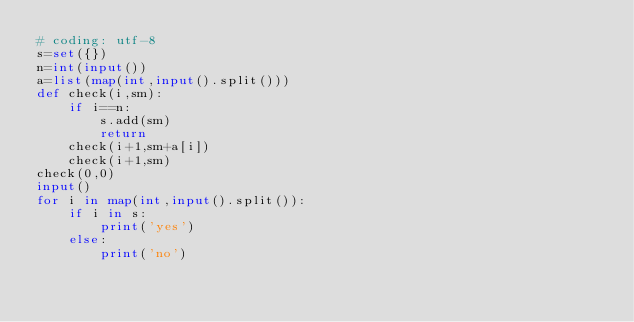<code> <loc_0><loc_0><loc_500><loc_500><_Python_># coding: utf-8
s=set({})
n=int(input())
a=list(map(int,input().split()))
def check(i,sm):
    if i==n:
        s.add(sm)
        return
    check(i+1,sm+a[i])
    check(i+1,sm)
check(0,0)
input()
for i in map(int,input().split()):
    if i in s:
        print('yes')
    else:
        print('no')

</code> 